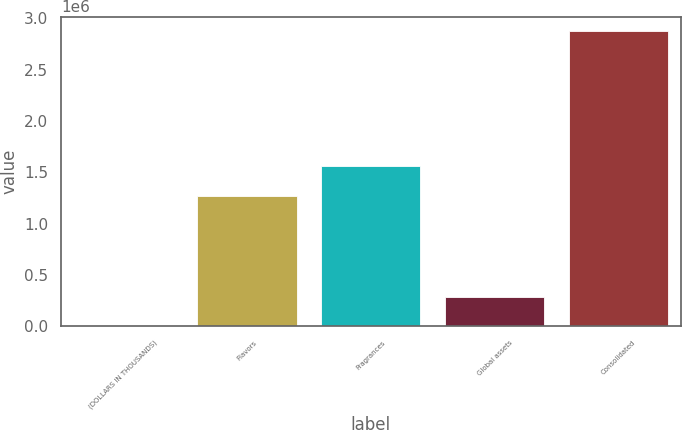Convert chart to OTSL. <chart><loc_0><loc_0><loc_500><loc_500><bar_chart><fcel>(DOLLARS IN THOUSANDS)<fcel>Flavors<fcel>Fragrances<fcel>Global assets<fcel>Consolidated<nl><fcel>2010<fcel>1.27313e+06<fcel>1.56017e+06<fcel>289054<fcel>2.87246e+06<nl></chart> 